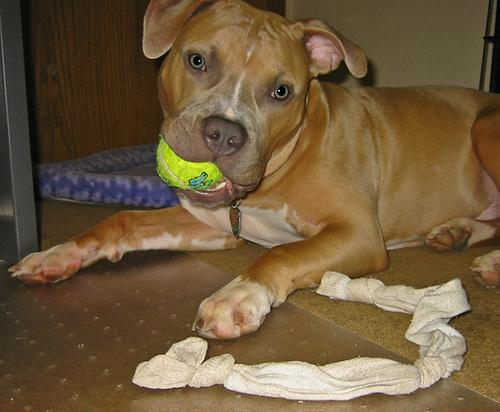What is the recommended training regimen for a breed like the one pictured? For a breed like the American Staffordshire Terrier pictured, consistent, early training and socialization are crucial. These dogs respond well to positive reinforcement techniques such as treats and praise. Regular, structured training sessions that focus on basic obedience, alongside ample social exposure, help mitigate potential aggression and ensure they are well-adjusted companions. 